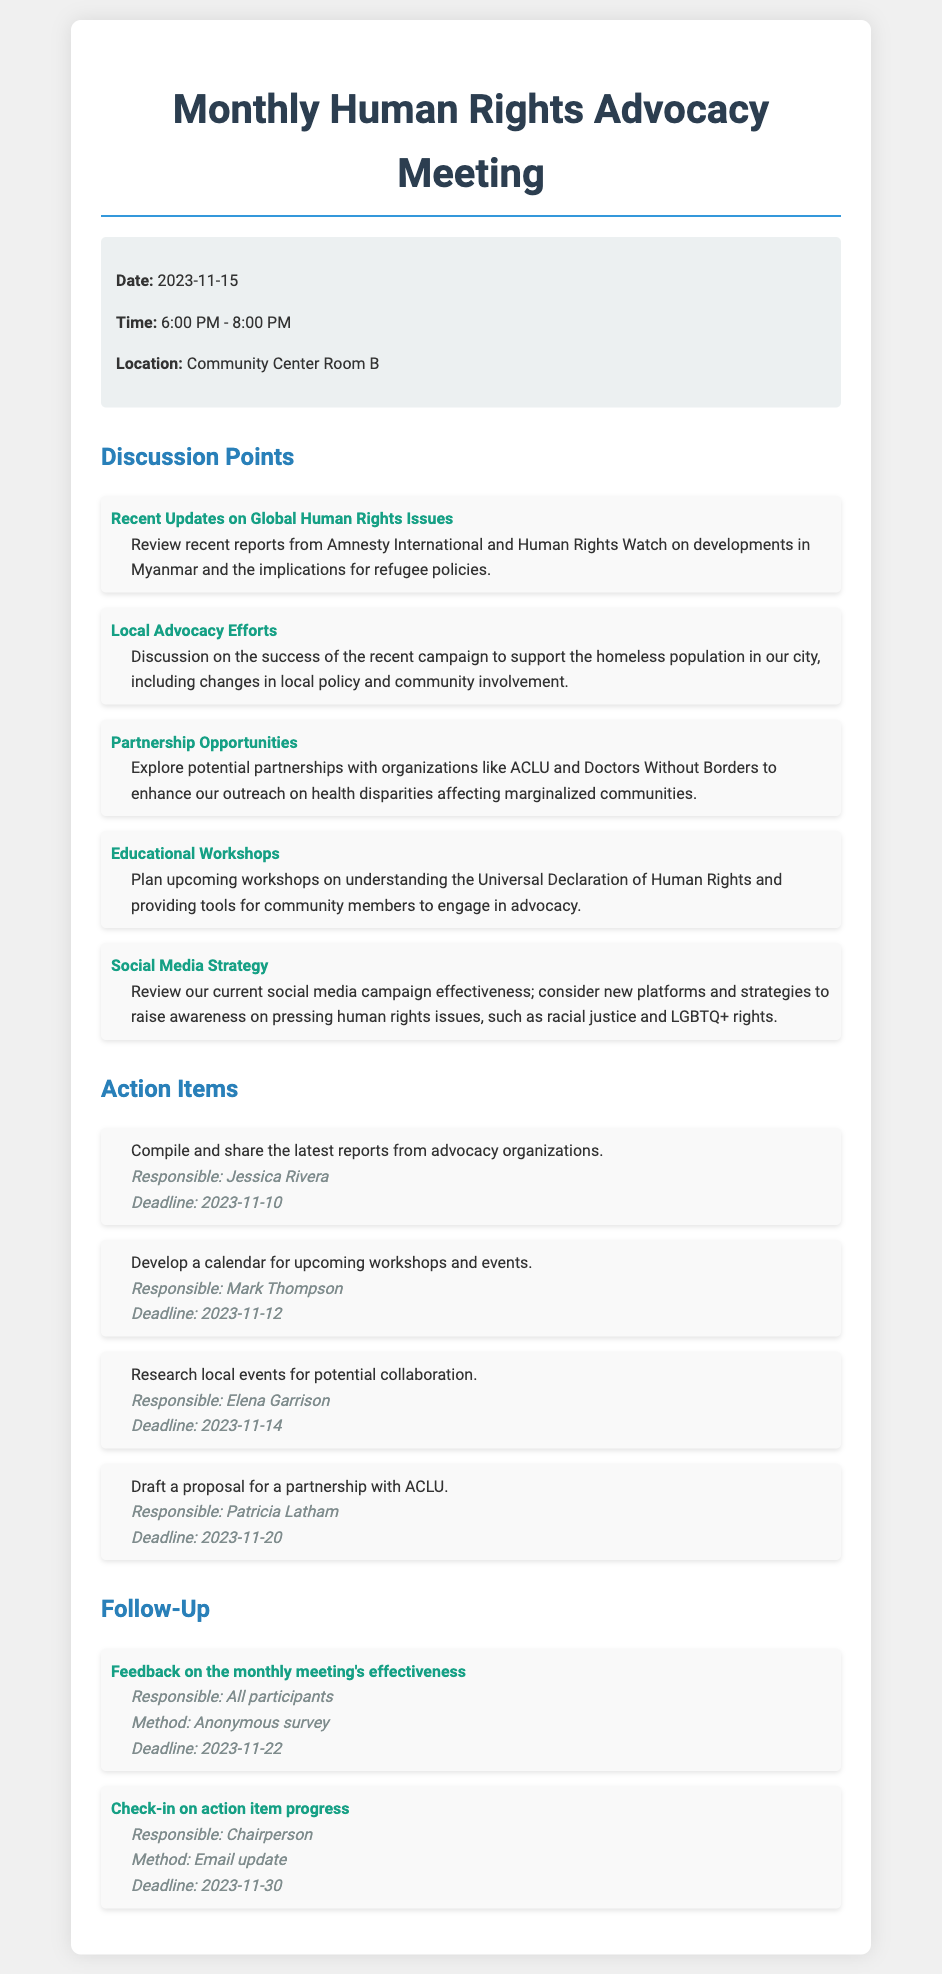what is the date of the meeting? The date of the meeting is mentioned in the document under the meeting information section.
Answer: 2023-11-15 who is responsible for compiling the latest reports? The document specifies the person responsible for each action item, including the compilation of reports.
Answer: Jessica Rivera what is the deadline for the proposal draft for ACLU? The document lists the deadlines associated with each action item, including the draft proposal.
Answer: 2023-11-20 which topic discusses partnership opportunities? The document lists different discussion points, indicating which concerns partnerships.
Answer: Partnership Opportunities what method is used for feedback collection? The document explains the method of obtaining feedback on the meeting's effectiveness.
Answer: Anonymous survey how long is the meeting scheduled to last? The meeting time section specifies the start and end times, allowing us to calculate the duration.
Answer: 2 hours which organization is mentioned in the context of health disparities? The document discusses potential partnerships with various organizations, one of which focuses on health.
Answer: Doctors Without Borders what is the upcoming event deadline for workshop calendar development? The deadline for developing the calendar for workshops is listed with the action items.
Answer: 2023-11-12 